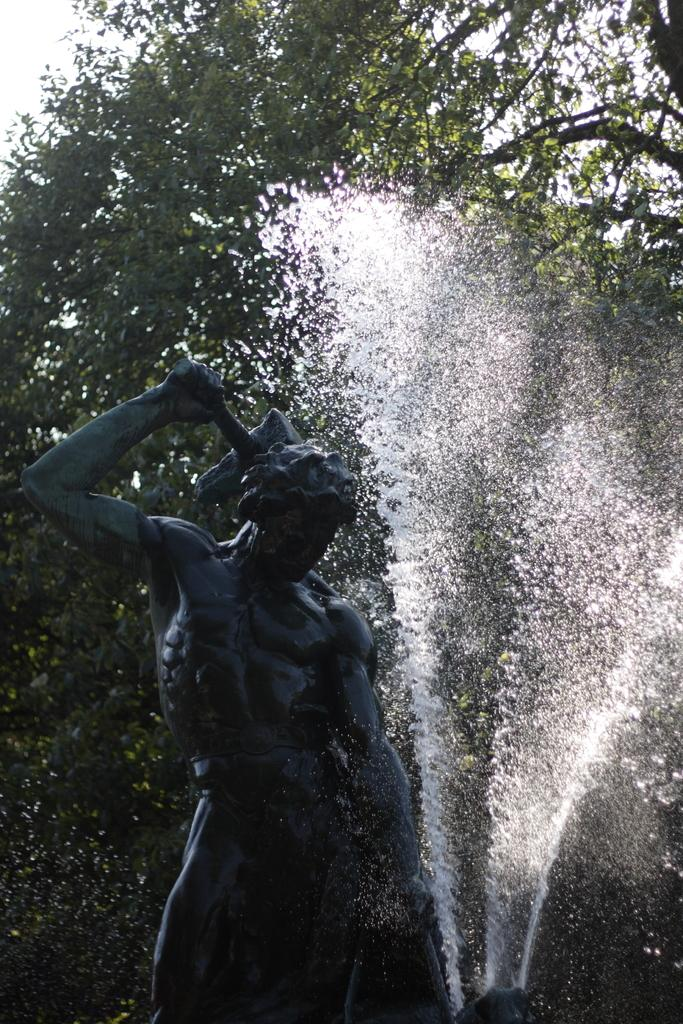What is the main subject of the image? There is a statue of a person in the image. What can be seen in the background of the image? Water, trees, and the sky are visible in the background of the image. What type of lumber is being used to build the statue in the image? There is no indication that the statue is made of lumber, as it is a statue of a person. On which side of the statue is the kite flying in the image? There is no kite present in the image. 